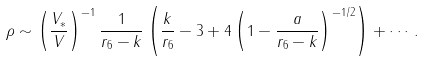<formula> <loc_0><loc_0><loc_500><loc_500>\rho \sim \left ( \frac { V _ { * } } { V } \right ) ^ { - 1 } \frac { 1 } { r _ { 6 } - k } \left ( \frac { k } { r _ { 6 } } - 3 + 4 \left ( 1 - \frac { a } { r _ { 6 } - k } \right ) ^ { - 1 / 2 } \right ) + \cdots \, .</formula> 